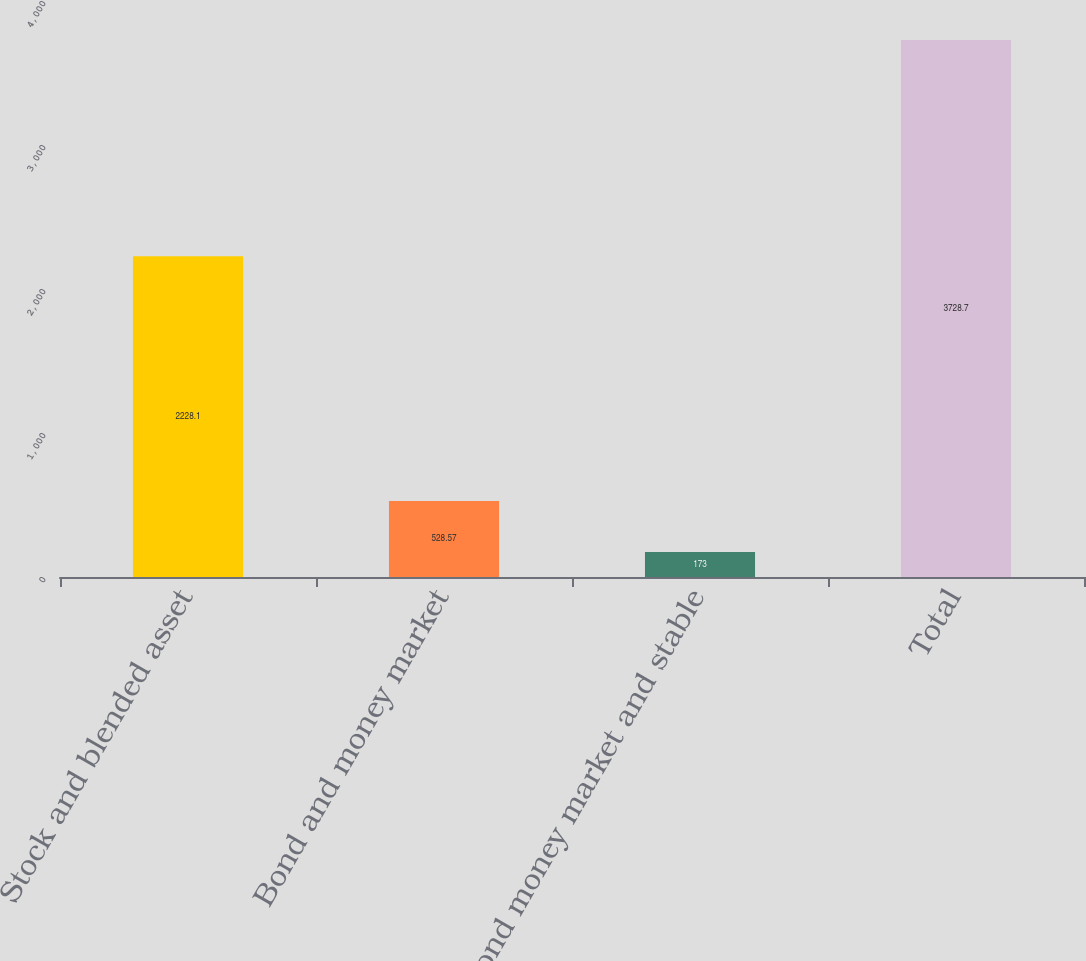Convert chart. <chart><loc_0><loc_0><loc_500><loc_500><bar_chart><fcel>Stock and blended asset<fcel>Bond and money market<fcel>Bond money market and stable<fcel>Total<nl><fcel>2228.1<fcel>528.57<fcel>173<fcel>3728.7<nl></chart> 